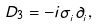<formula> <loc_0><loc_0><loc_500><loc_500>D _ { 3 } = - i \sigma _ { _ { i } } \partial _ { _ { i } } ,</formula> 